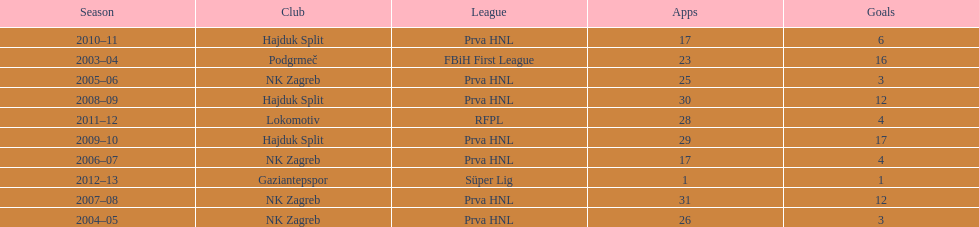What were the names of each club where more than 15 goals were scored in a single season? Podgrmeč, Hajduk Split. 